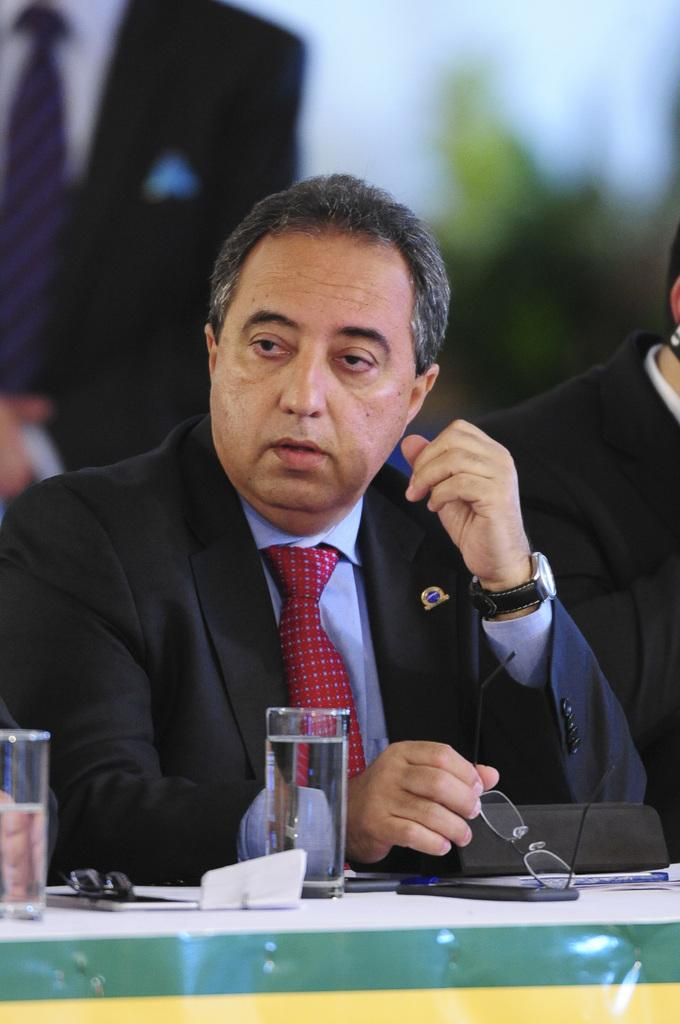How many men are in the image? There are two men in the image. What are the men doing in the image? The men are sitting at a table. What are the men wearing in the image? Both men are wearing suits. What can be seen on the table in the image? There are two glasses, two mobile phones, and other items on the table. Can you describe the background of the image? There are other people in the background of the image. What type of cheese is being served on the table in the image? There is no cheese present in the image. What story are the men discussing at the table in the image? There is no indication of a story being discussed in the image. 